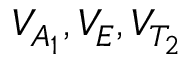Convert formula to latex. <formula><loc_0><loc_0><loc_500><loc_500>V _ { A _ { 1 } } , V _ { E } , V _ { T _ { 2 } }</formula> 